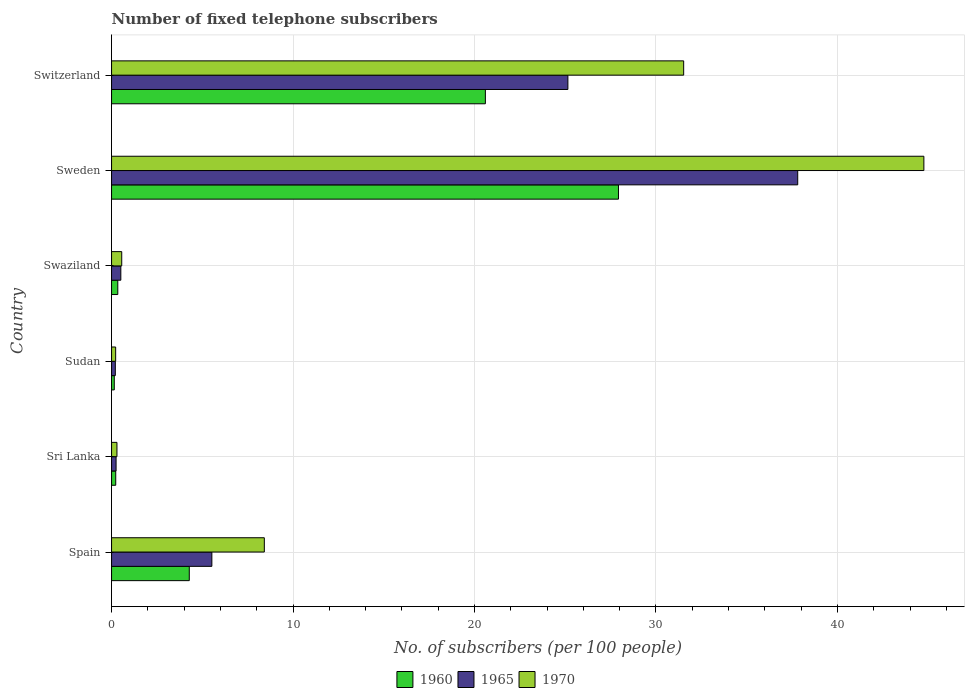How many different coloured bars are there?
Your answer should be very brief. 3. How many bars are there on the 5th tick from the top?
Offer a terse response. 3. What is the label of the 4th group of bars from the top?
Ensure brevity in your answer.  Sudan. In how many cases, is the number of bars for a given country not equal to the number of legend labels?
Offer a terse response. 0. What is the number of fixed telephone subscribers in 1965 in Sri Lanka?
Provide a succinct answer. 0.25. Across all countries, what is the maximum number of fixed telephone subscribers in 1960?
Make the answer very short. 27.93. Across all countries, what is the minimum number of fixed telephone subscribers in 1965?
Your answer should be compact. 0.21. In which country was the number of fixed telephone subscribers in 1960 maximum?
Make the answer very short. Sweden. In which country was the number of fixed telephone subscribers in 1965 minimum?
Your response must be concise. Sudan. What is the total number of fixed telephone subscribers in 1970 in the graph?
Your answer should be compact. 85.79. What is the difference between the number of fixed telephone subscribers in 1965 in Sudan and that in Sweden?
Offer a very short reply. -37.6. What is the difference between the number of fixed telephone subscribers in 1970 in Spain and the number of fixed telephone subscribers in 1960 in Switzerland?
Offer a very short reply. -12.18. What is the average number of fixed telephone subscribers in 1970 per country?
Ensure brevity in your answer.  14.3. What is the difference between the number of fixed telephone subscribers in 1965 and number of fixed telephone subscribers in 1970 in Switzerland?
Ensure brevity in your answer.  -6.38. What is the ratio of the number of fixed telephone subscribers in 1970 in Sudan to that in Switzerland?
Offer a very short reply. 0.01. What is the difference between the highest and the second highest number of fixed telephone subscribers in 1965?
Offer a terse response. 12.66. What is the difference between the highest and the lowest number of fixed telephone subscribers in 1965?
Keep it short and to the point. 37.6. What does the 1st bar from the top in Swaziland represents?
Your answer should be compact. 1970. What does the 2nd bar from the bottom in Sri Lanka represents?
Your answer should be very brief. 1965. How many bars are there?
Provide a short and direct response. 18. Are all the bars in the graph horizontal?
Ensure brevity in your answer.  Yes. Where does the legend appear in the graph?
Your answer should be very brief. Bottom center. What is the title of the graph?
Your response must be concise. Number of fixed telephone subscribers. What is the label or title of the X-axis?
Ensure brevity in your answer.  No. of subscribers (per 100 people). What is the No. of subscribers (per 100 people) of 1960 in Spain?
Your response must be concise. 4.28. What is the No. of subscribers (per 100 people) of 1965 in Spain?
Ensure brevity in your answer.  5.53. What is the No. of subscribers (per 100 people) in 1970 in Spain?
Offer a very short reply. 8.42. What is the No. of subscribers (per 100 people) of 1960 in Sri Lanka?
Your answer should be very brief. 0.23. What is the No. of subscribers (per 100 people) in 1965 in Sri Lanka?
Provide a succinct answer. 0.25. What is the No. of subscribers (per 100 people) in 1970 in Sri Lanka?
Offer a very short reply. 0.3. What is the No. of subscribers (per 100 people) of 1960 in Sudan?
Give a very brief answer. 0.15. What is the No. of subscribers (per 100 people) in 1965 in Sudan?
Ensure brevity in your answer.  0.21. What is the No. of subscribers (per 100 people) of 1970 in Sudan?
Your response must be concise. 0.23. What is the No. of subscribers (per 100 people) of 1960 in Swaziland?
Give a very brief answer. 0.34. What is the No. of subscribers (per 100 people) of 1965 in Swaziland?
Your response must be concise. 0.51. What is the No. of subscribers (per 100 people) in 1970 in Swaziland?
Offer a terse response. 0.56. What is the No. of subscribers (per 100 people) in 1960 in Sweden?
Offer a very short reply. 27.93. What is the No. of subscribers (per 100 people) of 1965 in Sweden?
Give a very brief answer. 37.81. What is the No. of subscribers (per 100 people) of 1970 in Sweden?
Your answer should be very brief. 44.76. What is the No. of subscribers (per 100 people) in 1960 in Switzerland?
Provide a succinct answer. 20.6. What is the No. of subscribers (per 100 people) of 1965 in Switzerland?
Offer a terse response. 25.15. What is the No. of subscribers (per 100 people) in 1970 in Switzerland?
Ensure brevity in your answer.  31.53. Across all countries, what is the maximum No. of subscribers (per 100 people) in 1960?
Provide a succinct answer. 27.93. Across all countries, what is the maximum No. of subscribers (per 100 people) in 1965?
Ensure brevity in your answer.  37.81. Across all countries, what is the maximum No. of subscribers (per 100 people) in 1970?
Your response must be concise. 44.76. Across all countries, what is the minimum No. of subscribers (per 100 people) of 1960?
Provide a succinct answer. 0.15. Across all countries, what is the minimum No. of subscribers (per 100 people) in 1965?
Your answer should be compact. 0.21. Across all countries, what is the minimum No. of subscribers (per 100 people) in 1970?
Your response must be concise. 0.23. What is the total No. of subscribers (per 100 people) in 1960 in the graph?
Give a very brief answer. 53.54. What is the total No. of subscribers (per 100 people) in 1965 in the graph?
Keep it short and to the point. 69.45. What is the total No. of subscribers (per 100 people) of 1970 in the graph?
Your response must be concise. 85.79. What is the difference between the No. of subscribers (per 100 people) in 1960 in Spain and that in Sri Lanka?
Provide a succinct answer. 4.05. What is the difference between the No. of subscribers (per 100 people) in 1965 in Spain and that in Sri Lanka?
Offer a terse response. 5.28. What is the difference between the No. of subscribers (per 100 people) in 1970 in Spain and that in Sri Lanka?
Provide a short and direct response. 8.12. What is the difference between the No. of subscribers (per 100 people) of 1960 in Spain and that in Sudan?
Your response must be concise. 4.13. What is the difference between the No. of subscribers (per 100 people) in 1965 in Spain and that in Sudan?
Keep it short and to the point. 5.32. What is the difference between the No. of subscribers (per 100 people) in 1970 in Spain and that in Sudan?
Provide a short and direct response. 8.19. What is the difference between the No. of subscribers (per 100 people) of 1960 in Spain and that in Swaziland?
Give a very brief answer. 3.94. What is the difference between the No. of subscribers (per 100 people) in 1965 in Spain and that in Swaziland?
Offer a terse response. 5.02. What is the difference between the No. of subscribers (per 100 people) of 1970 in Spain and that in Swaziland?
Offer a very short reply. 7.86. What is the difference between the No. of subscribers (per 100 people) of 1960 in Spain and that in Sweden?
Your answer should be very brief. -23.65. What is the difference between the No. of subscribers (per 100 people) of 1965 in Spain and that in Sweden?
Your answer should be compact. -32.28. What is the difference between the No. of subscribers (per 100 people) of 1970 in Spain and that in Sweden?
Your response must be concise. -36.34. What is the difference between the No. of subscribers (per 100 people) in 1960 in Spain and that in Switzerland?
Provide a short and direct response. -16.32. What is the difference between the No. of subscribers (per 100 people) of 1965 in Spain and that in Switzerland?
Your answer should be compact. -19.62. What is the difference between the No. of subscribers (per 100 people) of 1970 in Spain and that in Switzerland?
Your answer should be very brief. -23.11. What is the difference between the No. of subscribers (per 100 people) in 1960 in Sri Lanka and that in Sudan?
Make the answer very short. 0.08. What is the difference between the No. of subscribers (per 100 people) in 1965 in Sri Lanka and that in Sudan?
Keep it short and to the point. 0.04. What is the difference between the No. of subscribers (per 100 people) of 1970 in Sri Lanka and that in Sudan?
Provide a short and direct response. 0.07. What is the difference between the No. of subscribers (per 100 people) of 1960 in Sri Lanka and that in Swaziland?
Keep it short and to the point. -0.11. What is the difference between the No. of subscribers (per 100 people) of 1965 in Sri Lanka and that in Swaziland?
Provide a succinct answer. -0.26. What is the difference between the No. of subscribers (per 100 people) of 1970 in Sri Lanka and that in Swaziland?
Your response must be concise. -0.26. What is the difference between the No. of subscribers (per 100 people) of 1960 in Sri Lanka and that in Sweden?
Provide a succinct answer. -27.7. What is the difference between the No. of subscribers (per 100 people) in 1965 in Sri Lanka and that in Sweden?
Keep it short and to the point. -37.56. What is the difference between the No. of subscribers (per 100 people) in 1970 in Sri Lanka and that in Sweden?
Make the answer very short. -44.47. What is the difference between the No. of subscribers (per 100 people) of 1960 in Sri Lanka and that in Switzerland?
Make the answer very short. -20.37. What is the difference between the No. of subscribers (per 100 people) in 1965 in Sri Lanka and that in Switzerland?
Make the answer very short. -24.9. What is the difference between the No. of subscribers (per 100 people) in 1970 in Sri Lanka and that in Switzerland?
Your answer should be compact. -31.23. What is the difference between the No. of subscribers (per 100 people) in 1960 in Sudan and that in Swaziland?
Your response must be concise. -0.19. What is the difference between the No. of subscribers (per 100 people) of 1965 in Sudan and that in Swaziland?
Your response must be concise. -0.3. What is the difference between the No. of subscribers (per 100 people) in 1970 in Sudan and that in Swaziland?
Ensure brevity in your answer.  -0.34. What is the difference between the No. of subscribers (per 100 people) of 1960 in Sudan and that in Sweden?
Your answer should be compact. -27.78. What is the difference between the No. of subscribers (per 100 people) in 1965 in Sudan and that in Sweden?
Provide a succinct answer. -37.6. What is the difference between the No. of subscribers (per 100 people) of 1970 in Sudan and that in Sweden?
Ensure brevity in your answer.  -44.54. What is the difference between the No. of subscribers (per 100 people) in 1960 in Sudan and that in Switzerland?
Provide a succinct answer. -20.45. What is the difference between the No. of subscribers (per 100 people) of 1965 in Sudan and that in Switzerland?
Offer a terse response. -24.94. What is the difference between the No. of subscribers (per 100 people) in 1970 in Sudan and that in Switzerland?
Keep it short and to the point. -31.3. What is the difference between the No. of subscribers (per 100 people) in 1960 in Swaziland and that in Sweden?
Your answer should be very brief. -27.59. What is the difference between the No. of subscribers (per 100 people) of 1965 in Swaziland and that in Sweden?
Offer a terse response. -37.3. What is the difference between the No. of subscribers (per 100 people) of 1970 in Swaziland and that in Sweden?
Your response must be concise. -44.2. What is the difference between the No. of subscribers (per 100 people) in 1960 in Swaziland and that in Switzerland?
Your answer should be compact. -20.26. What is the difference between the No. of subscribers (per 100 people) in 1965 in Swaziland and that in Switzerland?
Keep it short and to the point. -24.64. What is the difference between the No. of subscribers (per 100 people) in 1970 in Swaziland and that in Switzerland?
Your response must be concise. -30.97. What is the difference between the No. of subscribers (per 100 people) in 1960 in Sweden and that in Switzerland?
Make the answer very short. 7.33. What is the difference between the No. of subscribers (per 100 people) in 1965 in Sweden and that in Switzerland?
Your answer should be very brief. 12.66. What is the difference between the No. of subscribers (per 100 people) of 1970 in Sweden and that in Switzerland?
Your answer should be very brief. 13.24. What is the difference between the No. of subscribers (per 100 people) in 1960 in Spain and the No. of subscribers (per 100 people) in 1965 in Sri Lanka?
Your response must be concise. 4.03. What is the difference between the No. of subscribers (per 100 people) of 1960 in Spain and the No. of subscribers (per 100 people) of 1970 in Sri Lanka?
Your answer should be very brief. 3.99. What is the difference between the No. of subscribers (per 100 people) of 1965 in Spain and the No. of subscribers (per 100 people) of 1970 in Sri Lanka?
Your answer should be very brief. 5.23. What is the difference between the No. of subscribers (per 100 people) of 1960 in Spain and the No. of subscribers (per 100 people) of 1965 in Sudan?
Give a very brief answer. 4.08. What is the difference between the No. of subscribers (per 100 people) of 1960 in Spain and the No. of subscribers (per 100 people) of 1970 in Sudan?
Your response must be concise. 4.06. What is the difference between the No. of subscribers (per 100 people) in 1965 in Spain and the No. of subscribers (per 100 people) in 1970 in Sudan?
Make the answer very short. 5.3. What is the difference between the No. of subscribers (per 100 people) in 1960 in Spain and the No. of subscribers (per 100 people) in 1965 in Swaziland?
Your answer should be compact. 3.77. What is the difference between the No. of subscribers (per 100 people) in 1960 in Spain and the No. of subscribers (per 100 people) in 1970 in Swaziland?
Your answer should be compact. 3.72. What is the difference between the No. of subscribers (per 100 people) of 1965 in Spain and the No. of subscribers (per 100 people) of 1970 in Swaziland?
Make the answer very short. 4.97. What is the difference between the No. of subscribers (per 100 people) of 1960 in Spain and the No. of subscribers (per 100 people) of 1965 in Sweden?
Your answer should be compact. -33.53. What is the difference between the No. of subscribers (per 100 people) in 1960 in Spain and the No. of subscribers (per 100 people) in 1970 in Sweden?
Offer a terse response. -40.48. What is the difference between the No. of subscribers (per 100 people) in 1965 in Spain and the No. of subscribers (per 100 people) in 1970 in Sweden?
Your response must be concise. -39.24. What is the difference between the No. of subscribers (per 100 people) of 1960 in Spain and the No. of subscribers (per 100 people) of 1965 in Switzerland?
Keep it short and to the point. -20.86. What is the difference between the No. of subscribers (per 100 people) of 1960 in Spain and the No. of subscribers (per 100 people) of 1970 in Switzerland?
Your response must be concise. -27.24. What is the difference between the No. of subscribers (per 100 people) of 1965 in Spain and the No. of subscribers (per 100 people) of 1970 in Switzerland?
Your answer should be compact. -26. What is the difference between the No. of subscribers (per 100 people) of 1960 in Sri Lanka and the No. of subscribers (per 100 people) of 1965 in Sudan?
Make the answer very short. 0.02. What is the difference between the No. of subscribers (per 100 people) in 1960 in Sri Lanka and the No. of subscribers (per 100 people) in 1970 in Sudan?
Your answer should be very brief. 0. What is the difference between the No. of subscribers (per 100 people) in 1965 in Sri Lanka and the No. of subscribers (per 100 people) in 1970 in Sudan?
Ensure brevity in your answer.  0.02. What is the difference between the No. of subscribers (per 100 people) in 1960 in Sri Lanka and the No. of subscribers (per 100 people) in 1965 in Swaziland?
Provide a succinct answer. -0.28. What is the difference between the No. of subscribers (per 100 people) of 1960 in Sri Lanka and the No. of subscribers (per 100 people) of 1970 in Swaziland?
Keep it short and to the point. -0.33. What is the difference between the No. of subscribers (per 100 people) of 1965 in Sri Lanka and the No. of subscribers (per 100 people) of 1970 in Swaziland?
Offer a terse response. -0.31. What is the difference between the No. of subscribers (per 100 people) of 1960 in Sri Lanka and the No. of subscribers (per 100 people) of 1965 in Sweden?
Offer a very short reply. -37.58. What is the difference between the No. of subscribers (per 100 people) of 1960 in Sri Lanka and the No. of subscribers (per 100 people) of 1970 in Sweden?
Give a very brief answer. -44.53. What is the difference between the No. of subscribers (per 100 people) in 1965 in Sri Lanka and the No. of subscribers (per 100 people) in 1970 in Sweden?
Your answer should be compact. -44.51. What is the difference between the No. of subscribers (per 100 people) of 1960 in Sri Lanka and the No. of subscribers (per 100 people) of 1965 in Switzerland?
Your response must be concise. -24.92. What is the difference between the No. of subscribers (per 100 people) of 1960 in Sri Lanka and the No. of subscribers (per 100 people) of 1970 in Switzerland?
Keep it short and to the point. -31.3. What is the difference between the No. of subscribers (per 100 people) in 1965 in Sri Lanka and the No. of subscribers (per 100 people) in 1970 in Switzerland?
Offer a very short reply. -31.28. What is the difference between the No. of subscribers (per 100 people) in 1960 in Sudan and the No. of subscribers (per 100 people) in 1965 in Swaziland?
Give a very brief answer. -0.36. What is the difference between the No. of subscribers (per 100 people) in 1960 in Sudan and the No. of subscribers (per 100 people) in 1970 in Swaziland?
Give a very brief answer. -0.41. What is the difference between the No. of subscribers (per 100 people) in 1965 in Sudan and the No. of subscribers (per 100 people) in 1970 in Swaziland?
Your answer should be very brief. -0.35. What is the difference between the No. of subscribers (per 100 people) in 1960 in Sudan and the No. of subscribers (per 100 people) in 1965 in Sweden?
Ensure brevity in your answer.  -37.66. What is the difference between the No. of subscribers (per 100 people) of 1960 in Sudan and the No. of subscribers (per 100 people) of 1970 in Sweden?
Keep it short and to the point. -44.61. What is the difference between the No. of subscribers (per 100 people) of 1965 in Sudan and the No. of subscribers (per 100 people) of 1970 in Sweden?
Keep it short and to the point. -44.56. What is the difference between the No. of subscribers (per 100 people) in 1960 in Sudan and the No. of subscribers (per 100 people) in 1965 in Switzerland?
Your answer should be very brief. -25. What is the difference between the No. of subscribers (per 100 people) of 1960 in Sudan and the No. of subscribers (per 100 people) of 1970 in Switzerland?
Provide a short and direct response. -31.38. What is the difference between the No. of subscribers (per 100 people) of 1965 in Sudan and the No. of subscribers (per 100 people) of 1970 in Switzerland?
Give a very brief answer. -31.32. What is the difference between the No. of subscribers (per 100 people) of 1960 in Swaziland and the No. of subscribers (per 100 people) of 1965 in Sweden?
Provide a succinct answer. -37.47. What is the difference between the No. of subscribers (per 100 people) in 1960 in Swaziland and the No. of subscribers (per 100 people) in 1970 in Sweden?
Keep it short and to the point. -44.42. What is the difference between the No. of subscribers (per 100 people) of 1965 in Swaziland and the No. of subscribers (per 100 people) of 1970 in Sweden?
Provide a short and direct response. -44.25. What is the difference between the No. of subscribers (per 100 people) of 1960 in Swaziland and the No. of subscribers (per 100 people) of 1965 in Switzerland?
Your answer should be compact. -24.8. What is the difference between the No. of subscribers (per 100 people) in 1960 in Swaziland and the No. of subscribers (per 100 people) in 1970 in Switzerland?
Offer a terse response. -31.18. What is the difference between the No. of subscribers (per 100 people) of 1965 in Swaziland and the No. of subscribers (per 100 people) of 1970 in Switzerland?
Make the answer very short. -31.02. What is the difference between the No. of subscribers (per 100 people) of 1960 in Sweden and the No. of subscribers (per 100 people) of 1965 in Switzerland?
Give a very brief answer. 2.79. What is the difference between the No. of subscribers (per 100 people) of 1960 in Sweden and the No. of subscribers (per 100 people) of 1970 in Switzerland?
Offer a terse response. -3.59. What is the difference between the No. of subscribers (per 100 people) in 1965 in Sweden and the No. of subscribers (per 100 people) in 1970 in Switzerland?
Offer a terse response. 6.28. What is the average No. of subscribers (per 100 people) in 1960 per country?
Your answer should be compact. 8.92. What is the average No. of subscribers (per 100 people) in 1965 per country?
Your response must be concise. 11.58. What is the average No. of subscribers (per 100 people) in 1970 per country?
Your response must be concise. 14.3. What is the difference between the No. of subscribers (per 100 people) in 1960 and No. of subscribers (per 100 people) in 1965 in Spain?
Provide a short and direct response. -1.24. What is the difference between the No. of subscribers (per 100 people) of 1960 and No. of subscribers (per 100 people) of 1970 in Spain?
Provide a short and direct response. -4.14. What is the difference between the No. of subscribers (per 100 people) in 1965 and No. of subscribers (per 100 people) in 1970 in Spain?
Your answer should be very brief. -2.89. What is the difference between the No. of subscribers (per 100 people) of 1960 and No. of subscribers (per 100 people) of 1965 in Sri Lanka?
Your answer should be compact. -0.02. What is the difference between the No. of subscribers (per 100 people) in 1960 and No. of subscribers (per 100 people) in 1970 in Sri Lanka?
Keep it short and to the point. -0.07. What is the difference between the No. of subscribers (per 100 people) of 1965 and No. of subscribers (per 100 people) of 1970 in Sri Lanka?
Make the answer very short. -0.05. What is the difference between the No. of subscribers (per 100 people) of 1960 and No. of subscribers (per 100 people) of 1965 in Sudan?
Your answer should be very brief. -0.06. What is the difference between the No. of subscribers (per 100 people) in 1960 and No. of subscribers (per 100 people) in 1970 in Sudan?
Your answer should be very brief. -0.08. What is the difference between the No. of subscribers (per 100 people) of 1965 and No. of subscribers (per 100 people) of 1970 in Sudan?
Keep it short and to the point. -0.02. What is the difference between the No. of subscribers (per 100 people) in 1960 and No. of subscribers (per 100 people) in 1965 in Swaziland?
Offer a very short reply. -0.17. What is the difference between the No. of subscribers (per 100 people) of 1960 and No. of subscribers (per 100 people) of 1970 in Swaziland?
Offer a terse response. -0.22. What is the difference between the No. of subscribers (per 100 people) in 1965 and No. of subscribers (per 100 people) in 1970 in Swaziland?
Give a very brief answer. -0.05. What is the difference between the No. of subscribers (per 100 people) in 1960 and No. of subscribers (per 100 people) in 1965 in Sweden?
Keep it short and to the point. -9.88. What is the difference between the No. of subscribers (per 100 people) in 1960 and No. of subscribers (per 100 people) in 1970 in Sweden?
Your response must be concise. -16.83. What is the difference between the No. of subscribers (per 100 people) of 1965 and No. of subscribers (per 100 people) of 1970 in Sweden?
Your response must be concise. -6.95. What is the difference between the No. of subscribers (per 100 people) in 1960 and No. of subscribers (per 100 people) in 1965 in Switzerland?
Offer a very short reply. -4.55. What is the difference between the No. of subscribers (per 100 people) of 1960 and No. of subscribers (per 100 people) of 1970 in Switzerland?
Your answer should be compact. -10.93. What is the difference between the No. of subscribers (per 100 people) in 1965 and No. of subscribers (per 100 people) in 1970 in Switzerland?
Your response must be concise. -6.38. What is the ratio of the No. of subscribers (per 100 people) of 1960 in Spain to that in Sri Lanka?
Ensure brevity in your answer.  18.61. What is the ratio of the No. of subscribers (per 100 people) of 1965 in Spain to that in Sri Lanka?
Ensure brevity in your answer.  22.18. What is the ratio of the No. of subscribers (per 100 people) in 1970 in Spain to that in Sri Lanka?
Make the answer very short. 28.33. What is the ratio of the No. of subscribers (per 100 people) of 1960 in Spain to that in Sudan?
Offer a terse response. 28.56. What is the ratio of the No. of subscribers (per 100 people) of 1965 in Spain to that in Sudan?
Provide a succinct answer. 26.65. What is the ratio of the No. of subscribers (per 100 people) of 1970 in Spain to that in Sudan?
Offer a terse response. 37.33. What is the ratio of the No. of subscribers (per 100 people) in 1960 in Spain to that in Swaziland?
Offer a very short reply. 12.46. What is the ratio of the No. of subscribers (per 100 people) in 1965 in Spain to that in Swaziland?
Offer a terse response. 10.82. What is the ratio of the No. of subscribers (per 100 people) in 1970 in Spain to that in Swaziland?
Your answer should be very brief. 15.01. What is the ratio of the No. of subscribers (per 100 people) of 1960 in Spain to that in Sweden?
Make the answer very short. 0.15. What is the ratio of the No. of subscribers (per 100 people) of 1965 in Spain to that in Sweden?
Provide a succinct answer. 0.15. What is the ratio of the No. of subscribers (per 100 people) in 1970 in Spain to that in Sweden?
Provide a short and direct response. 0.19. What is the ratio of the No. of subscribers (per 100 people) in 1960 in Spain to that in Switzerland?
Your response must be concise. 0.21. What is the ratio of the No. of subscribers (per 100 people) in 1965 in Spain to that in Switzerland?
Your answer should be very brief. 0.22. What is the ratio of the No. of subscribers (per 100 people) in 1970 in Spain to that in Switzerland?
Your answer should be very brief. 0.27. What is the ratio of the No. of subscribers (per 100 people) in 1960 in Sri Lanka to that in Sudan?
Offer a very short reply. 1.53. What is the ratio of the No. of subscribers (per 100 people) of 1965 in Sri Lanka to that in Sudan?
Your answer should be very brief. 1.2. What is the ratio of the No. of subscribers (per 100 people) of 1970 in Sri Lanka to that in Sudan?
Provide a succinct answer. 1.32. What is the ratio of the No. of subscribers (per 100 people) in 1960 in Sri Lanka to that in Swaziland?
Your response must be concise. 0.67. What is the ratio of the No. of subscribers (per 100 people) in 1965 in Sri Lanka to that in Swaziland?
Offer a very short reply. 0.49. What is the ratio of the No. of subscribers (per 100 people) of 1970 in Sri Lanka to that in Swaziland?
Your answer should be compact. 0.53. What is the ratio of the No. of subscribers (per 100 people) of 1960 in Sri Lanka to that in Sweden?
Keep it short and to the point. 0.01. What is the ratio of the No. of subscribers (per 100 people) in 1965 in Sri Lanka to that in Sweden?
Provide a short and direct response. 0.01. What is the ratio of the No. of subscribers (per 100 people) in 1970 in Sri Lanka to that in Sweden?
Ensure brevity in your answer.  0.01. What is the ratio of the No. of subscribers (per 100 people) in 1960 in Sri Lanka to that in Switzerland?
Your answer should be very brief. 0.01. What is the ratio of the No. of subscribers (per 100 people) in 1965 in Sri Lanka to that in Switzerland?
Make the answer very short. 0.01. What is the ratio of the No. of subscribers (per 100 people) in 1970 in Sri Lanka to that in Switzerland?
Keep it short and to the point. 0.01. What is the ratio of the No. of subscribers (per 100 people) in 1960 in Sudan to that in Swaziland?
Your answer should be compact. 0.44. What is the ratio of the No. of subscribers (per 100 people) of 1965 in Sudan to that in Swaziland?
Offer a terse response. 0.41. What is the ratio of the No. of subscribers (per 100 people) of 1970 in Sudan to that in Swaziland?
Ensure brevity in your answer.  0.4. What is the ratio of the No. of subscribers (per 100 people) of 1960 in Sudan to that in Sweden?
Your answer should be very brief. 0.01. What is the ratio of the No. of subscribers (per 100 people) in 1965 in Sudan to that in Sweden?
Your response must be concise. 0.01. What is the ratio of the No. of subscribers (per 100 people) of 1970 in Sudan to that in Sweden?
Provide a short and direct response. 0.01. What is the ratio of the No. of subscribers (per 100 people) in 1960 in Sudan to that in Switzerland?
Your answer should be compact. 0.01. What is the ratio of the No. of subscribers (per 100 people) in 1965 in Sudan to that in Switzerland?
Your answer should be very brief. 0.01. What is the ratio of the No. of subscribers (per 100 people) of 1970 in Sudan to that in Switzerland?
Your answer should be compact. 0.01. What is the ratio of the No. of subscribers (per 100 people) in 1960 in Swaziland to that in Sweden?
Your response must be concise. 0.01. What is the ratio of the No. of subscribers (per 100 people) of 1965 in Swaziland to that in Sweden?
Keep it short and to the point. 0.01. What is the ratio of the No. of subscribers (per 100 people) of 1970 in Swaziland to that in Sweden?
Make the answer very short. 0.01. What is the ratio of the No. of subscribers (per 100 people) of 1960 in Swaziland to that in Switzerland?
Provide a succinct answer. 0.02. What is the ratio of the No. of subscribers (per 100 people) of 1965 in Swaziland to that in Switzerland?
Provide a succinct answer. 0.02. What is the ratio of the No. of subscribers (per 100 people) in 1970 in Swaziland to that in Switzerland?
Give a very brief answer. 0.02. What is the ratio of the No. of subscribers (per 100 people) of 1960 in Sweden to that in Switzerland?
Your answer should be very brief. 1.36. What is the ratio of the No. of subscribers (per 100 people) in 1965 in Sweden to that in Switzerland?
Ensure brevity in your answer.  1.5. What is the ratio of the No. of subscribers (per 100 people) of 1970 in Sweden to that in Switzerland?
Offer a very short reply. 1.42. What is the difference between the highest and the second highest No. of subscribers (per 100 people) in 1960?
Give a very brief answer. 7.33. What is the difference between the highest and the second highest No. of subscribers (per 100 people) of 1965?
Ensure brevity in your answer.  12.66. What is the difference between the highest and the second highest No. of subscribers (per 100 people) of 1970?
Keep it short and to the point. 13.24. What is the difference between the highest and the lowest No. of subscribers (per 100 people) of 1960?
Provide a succinct answer. 27.78. What is the difference between the highest and the lowest No. of subscribers (per 100 people) of 1965?
Make the answer very short. 37.6. What is the difference between the highest and the lowest No. of subscribers (per 100 people) of 1970?
Provide a succinct answer. 44.54. 